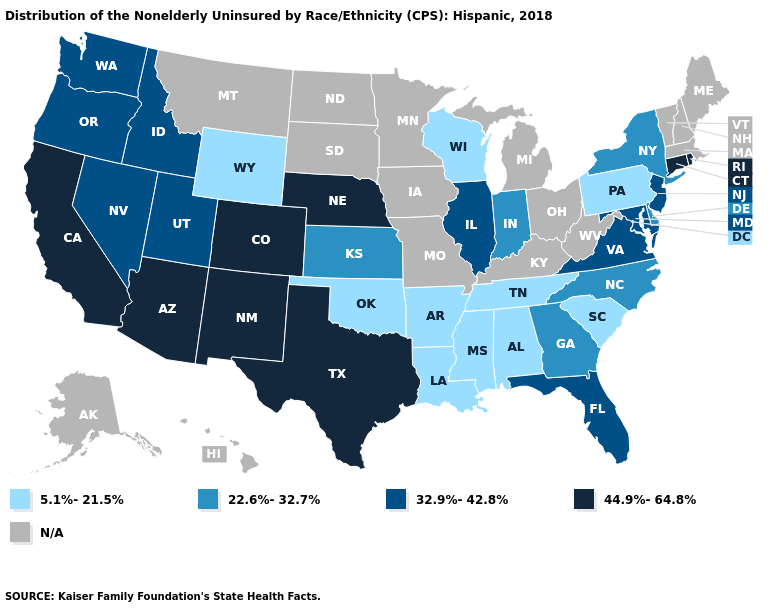What is the value of Nebraska?
Give a very brief answer. 44.9%-64.8%. Name the states that have a value in the range 44.9%-64.8%?
Keep it brief. Arizona, California, Colorado, Connecticut, Nebraska, New Mexico, Rhode Island, Texas. Which states have the highest value in the USA?
Write a very short answer. Arizona, California, Colorado, Connecticut, Nebraska, New Mexico, Rhode Island, Texas. What is the value of Mississippi?
Quick response, please. 5.1%-21.5%. Name the states that have a value in the range 22.6%-32.7%?
Short answer required. Delaware, Georgia, Indiana, Kansas, New York, North Carolina. Which states have the highest value in the USA?
Concise answer only. Arizona, California, Colorado, Connecticut, Nebraska, New Mexico, Rhode Island, Texas. What is the value of Massachusetts?
Quick response, please. N/A. Does the map have missing data?
Write a very short answer. Yes. What is the value of Virginia?
Answer briefly. 32.9%-42.8%. Does the first symbol in the legend represent the smallest category?
Be succinct. Yes. Does Florida have the lowest value in the South?
Keep it brief. No. What is the highest value in the Northeast ?
Short answer required. 44.9%-64.8%. What is the value of Nebraska?
Give a very brief answer. 44.9%-64.8%. Name the states that have a value in the range N/A?
Quick response, please. Alaska, Hawaii, Iowa, Kentucky, Maine, Massachusetts, Michigan, Minnesota, Missouri, Montana, New Hampshire, North Dakota, Ohio, South Dakota, Vermont, West Virginia. 